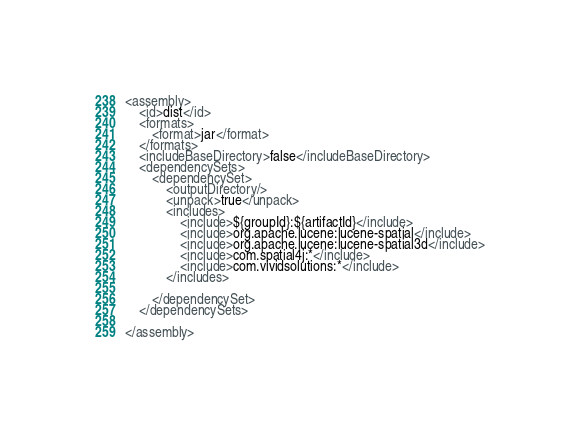<code> <loc_0><loc_0><loc_500><loc_500><_XML_><assembly>
    <id>dist</id>
    <formats>
        <format>jar</format>
    </formats>
    <includeBaseDirectory>false</includeBaseDirectory>
    <dependencySets>
        <dependencySet>
            <outputDirectory/>
            <unpack>true</unpack>
            <includes>
                <include>${groupId}:${artifactId}</include>
                <include>org.apache.lucene:lucene-spatial</include>
                <include>org.apache.lucene:lucene-spatial3d</include>
                <include>com.spatial4j:*</include>
                <include>com.vividsolutions:*</include>
            </includes>

        </dependencySet>
    </dependencySets>

</assembly></code> 